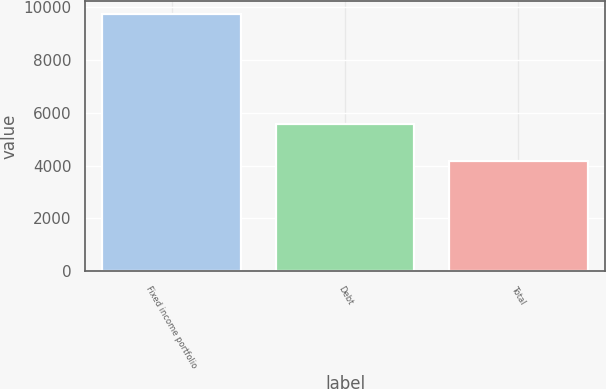Convert chart. <chart><loc_0><loc_0><loc_500><loc_500><bar_chart><fcel>Fixed income portfolio<fcel>Debt<fcel>Total<nl><fcel>9757<fcel>5567<fcel>4190<nl></chart> 